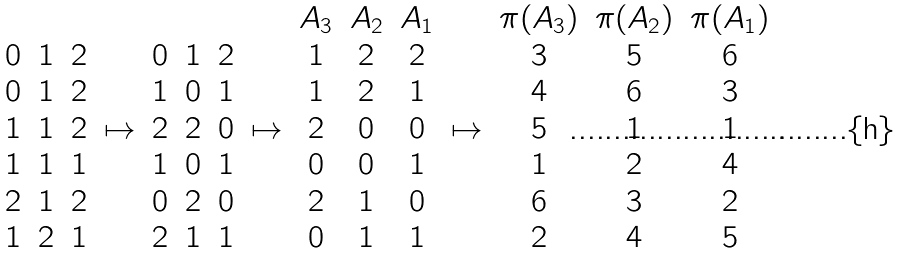Convert formula to latex. <formula><loc_0><loc_0><loc_500><loc_500>\begin{array} { c c c } & & \\ 0 & 1 & 2 \\ 0 & 1 & 2 \\ 1 & 1 & 2 \\ 1 & 1 & 1 \\ 2 & 1 & 2 \\ 1 & 2 & 1 \end{array} \mapsto \begin{array} { c c c } & & \\ 0 & 1 & 2 \\ 1 & 0 & 1 \\ 2 & 2 & 0 \\ 1 & 0 & 1 \\ 0 & 2 & 0 \\ 2 & 1 & 1 \end{array} \mapsto \begin{array} { c c c } A _ { 3 } & A _ { 2 } & A _ { 1 } \\ 1 & 2 & 2 \\ 1 & 2 & 1 \\ 2 & 0 & 0 \\ 0 & 0 & 1 \\ 2 & 1 & 0 \\ 0 & 1 & 1 \end{array} \mapsto \begin{array} { c c c } \pi ( A _ { 3 } ) & \pi ( A _ { 2 } ) & \pi ( A _ { 1 } ) \\ 3 & 5 & 6 \\ 4 & 6 & 3 \\ 5 & 1 & 1 \\ 1 & 2 & 4 \\ 6 & 3 & 2 \\ 2 & 4 & 5 \end{array} .</formula> 